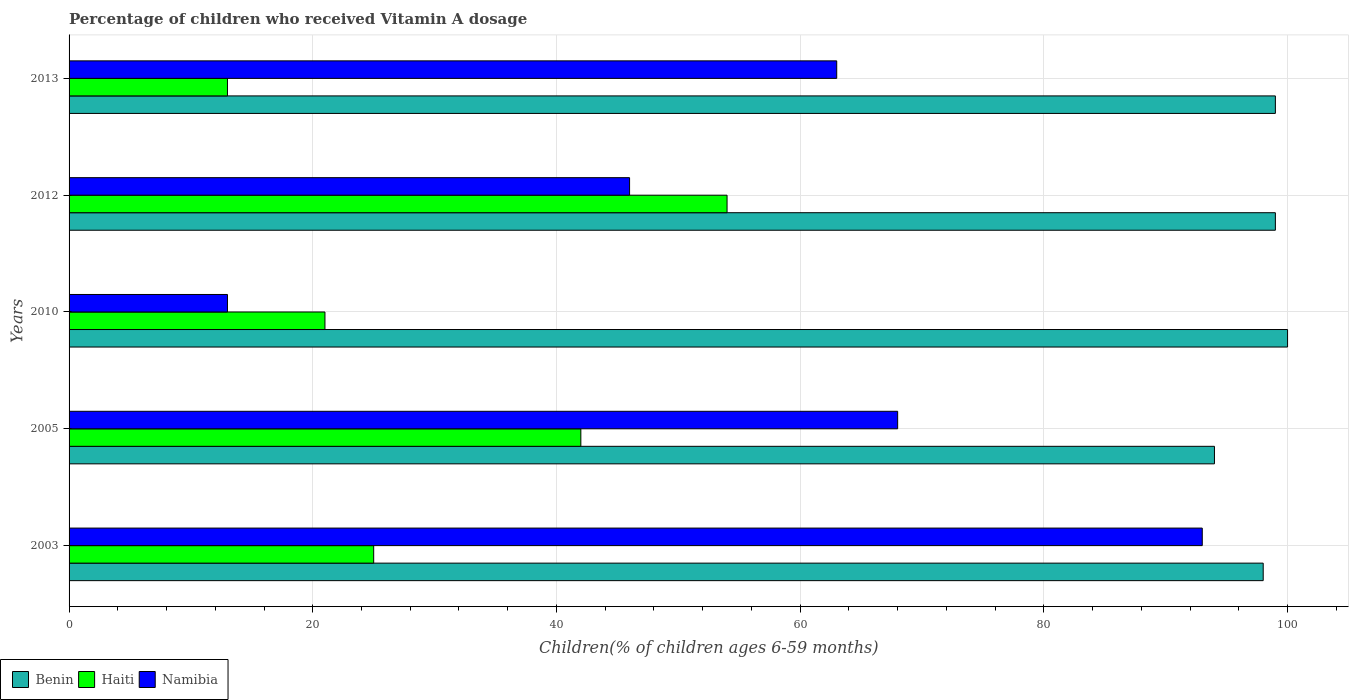How many different coloured bars are there?
Give a very brief answer. 3. What is the label of the 5th group of bars from the top?
Your response must be concise. 2003. What is the percentage of children who received Vitamin A dosage in Haiti in 2003?
Give a very brief answer. 25. Across all years, what is the maximum percentage of children who received Vitamin A dosage in Namibia?
Offer a very short reply. 93. Across all years, what is the minimum percentage of children who received Vitamin A dosage in Haiti?
Keep it short and to the point. 13. In which year was the percentage of children who received Vitamin A dosage in Namibia maximum?
Keep it short and to the point. 2003. In which year was the percentage of children who received Vitamin A dosage in Benin minimum?
Provide a short and direct response. 2005. What is the total percentage of children who received Vitamin A dosage in Haiti in the graph?
Provide a short and direct response. 155. What is the difference between the percentage of children who received Vitamin A dosage in Benin in 2005 and that in 2012?
Provide a short and direct response. -5. What is the difference between the percentage of children who received Vitamin A dosage in Namibia in 2013 and the percentage of children who received Vitamin A dosage in Benin in 2003?
Your response must be concise. -35. What is the average percentage of children who received Vitamin A dosage in Benin per year?
Offer a very short reply. 98. Is the difference between the percentage of children who received Vitamin A dosage in Namibia in 2005 and 2012 greater than the difference between the percentage of children who received Vitamin A dosage in Haiti in 2005 and 2012?
Offer a terse response. Yes. What is the difference between the highest and the second highest percentage of children who received Vitamin A dosage in Namibia?
Offer a very short reply. 25. What is the difference between the highest and the lowest percentage of children who received Vitamin A dosage in Haiti?
Make the answer very short. 41. In how many years, is the percentage of children who received Vitamin A dosage in Benin greater than the average percentage of children who received Vitamin A dosage in Benin taken over all years?
Offer a terse response. 3. What does the 1st bar from the top in 2010 represents?
Your response must be concise. Namibia. What does the 1st bar from the bottom in 2013 represents?
Your answer should be compact. Benin. Are all the bars in the graph horizontal?
Provide a short and direct response. Yes. What is the difference between two consecutive major ticks on the X-axis?
Make the answer very short. 20. Are the values on the major ticks of X-axis written in scientific E-notation?
Your answer should be very brief. No. Does the graph contain grids?
Offer a terse response. Yes. Where does the legend appear in the graph?
Keep it short and to the point. Bottom left. How are the legend labels stacked?
Give a very brief answer. Horizontal. What is the title of the graph?
Make the answer very short. Percentage of children who received Vitamin A dosage. Does "Bahrain" appear as one of the legend labels in the graph?
Offer a very short reply. No. What is the label or title of the X-axis?
Your response must be concise. Children(% of children ages 6-59 months). What is the label or title of the Y-axis?
Provide a succinct answer. Years. What is the Children(% of children ages 6-59 months) in Namibia in 2003?
Offer a very short reply. 93. What is the Children(% of children ages 6-59 months) in Benin in 2005?
Ensure brevity in your answer.  94. What is the Children(% of children ages 6-59 months) of Haiti in 2005?
Your answer should be compact. 42. What is the Children(% of children ages 6-59 months) in Namibia in 2005?
Ensure brevity in your answer.  68. What is the Children(% of children ages 6-59 months) of Benin in 2010?
Your answer should be compact. 100. What is the Children(% of children ages 6-59 months) of Haiti in 2012?
Make the answer very short. 54. What is the Children(% of children ages 6-59 months) of Haiti in 2013?
Your response must be concise. 13. Across all years, what is the maximum Children(% of children ages 6-59 months) in Benin?
Ensure brevity in your answer.  100. Across all years, what is the maximum Children(% of children ages 6-59 months) in Haiti?
Your answer should be compact. 54. Across all years, what is the maximum Children(% of children ages 6-59 months) of Namibia?
Keep it short and to the point. 93. Across all years, what is the minimum Children(% of children ages 6-59 months) in Benin?
Your response must be concise. 94. Across all years, what is the minimum Children(% of children ages 6-59 months) in Haiti?
Offer a terse response. 13. Across all years, what is the minimum Children(% of children ages 6-59 months) in Namibia?
Provide a succinct answer. 13. What is the total Children(% of children ages 6-59 months) of Benin in the graph?
Your answer should be compact. 490. What is the total Children(% of children ages 6-59 months) of Haiti in the graph?
Your answer should be compact. 155. What is the total Children(% of children ages 6-59 months) in Namibia in the graph?
Your answer should be very brief. 283. What is the difference between the Children(% of children ages 6-59 months) of Haiti in 2003 and that in 2005?
Ensure brevity in your answer.  -17. What is the difference between the Children(% of children ages 6-59 months) in Benin in 2003 and that in 2010?
Your answer should be compact. -2. What is the difference between the Children(% of children ages 6-59 months) of Haiti in 2003 and that in 2010?
Keep it short and to the point. 4. What is the difference between the Children(% of children ages 6-59 months) of Benin in 2003 and that in 2012?
Offer a terse response. -1. What is the difference between the Children(% of children ages 6-59 months) of Namibia in 2003 and that in 2012?
Provide a succinct answer. 47. What is the difference between the Children(% of children ages 6-59 months) of Benin in 2003 and that in 2013?
Your response must be concise. -1. What is the difference between the Children(% of children ages 6-59 months) of Namibia in 2003 and that in 2013?
Your answer should be compact. 30. What is the difference between the Children(% of children ages 6-59 months) of Haiti in 2005 and that in 2010?
Keep it short and to the point. 21. What is the difference between the Children(% of children ages 6-59 months) of Benin in 2005 and that in 2012?
Provide a short and direct response. -5. What is the difference between the Children(% of children ages 6-59 months) in Namibia in 2005 and that in 2012?
Give a very brief answer. 22. What is the difference between the Children(% of children ages 6-59 months) in Benin in 2005 and that in 2013?
Give a very brief answer. -5. What is the difference between the Children(% of children ages 6-59 months) in Haiti in 2005 and that in 2013?
Your response must be concise. 29. What is the difference between the Children(% of children ages 6-59 months) of Benin in 2010 and that in 2012?
Give a very brief answer. 1. What is the difference between the Children(% of children ages 6-59 months) of Haiti in 2010 and that in 2012?
Offer a very short reply. -33. What is the difference between the Children(% of children ages 6-59 months) in Namibia in 2010 and that in 2012?
Ensure brevity in your answer.  -33. What is the difference between the Children(% of children ages 6-59 months) in Benin in 2010 and that in 2013?
Provide a short and direct response. 1. What is the difference between the Children(% of children ages 6-59 months) in Haiti in 2010 and that in 2013?
Give a very brief answer. 8. What is the difference between the Children(% of children ages 6-59 months) of Benin in 2012 and that in 2013?
Provide a succinct answer. 0. What is the difference between the Children(% of children ages 6-59 months) of Benin in 2003 and the Children(% of children ages 6-59 months) of Haiti in 2005?
Give a very brief answer. 56. What is the difference between the Children(% of children ages 6-59 months) of Benin in 2003 and the Children(% of children ages 6-59 months) of Namibia in 2005?
Make the answer very short. 30. What is the difference between the Children(% of children ages 6-59 months) in Haiti in 2003 and the Children(% of children ages 6-59 months) in Namibia in 2005?
Provide a short and direct response. -43. What is the difference between the Children(% of children ages 6-59 months) of Benin in 2003 and the Children(% of children ages 6-59 months) of Haiti in 2010?
Provide a succinct answer. 77. What is the difference between the Children(% of children ages 6-59 months) in Haiti in 2003 and the Children(% of children ages 6-59 months) in Namibia in 2010?
Give a very brief answer. 12. What is the difference between the Children(% of children ages 6-59 months) of Benin in 2003 and the Children(% of children ages 6-59 months) of Namibia in 2012?
Make the answer very short. 52. What is the difference between the Children(% of children ages 6-59 months) in Haiti in 2003 and the Children(% of children ages 6-59 months) in Namibia in 2012?
Offer a terse response. -21. What is the difference between the Children(% of children ages 6-59 months) of Benin in 2003 and the Children(% of children ages 6-59 months) of Namibia in 2013?
Provide a succinct answer. 35. What is the difference between the Children(% of children ages 6-59 months) of Haiti in 2003 and the Children(% of children ages 6-59 months) of Namibia in 2013?
Your response must be concise. -38. What is the difference between the Children(% of children ages 6-59 months) of Haiti in 2005 and the Children(% of children ages 6-59 months) of Namibia in 2010?
Ensure brevity in your answer.  29. What is the difference between the Children(% of children ages 6-59 months) in Haiti in 2005 and the Children(% of children ages 6-59 months) in Namibia in 2012?
Give a very brief answer. -4. What is the difference between the Children(% of children ages 6-59 months) in Benin in 2005 and the Children(% of children ages 6-59 months) in Haiti in 2013?
Your answer should be very brief. 81. What is the difference between the Children(% of children ages 6-59 months) in Benin in 2005 and the Children(% of children ages 6-59 months) in Namibia in 2013?
Provide a succinct answer. 31. What is the difference between the Children(% of children ages 6-59 months) of Haiti in 2005 and the Children(% of children ages 6-59 months) of Namibia in 2013?
Keep it short and to the point. -21. What is the difference between the Children(% of children ages 6-59 months) in Benin in 2010 and the Children(% of children ages 6-59 months) in Namibia in 2012?
Keep it short and to the point. 54. What is the difference between the Children(% of children ages 6-59 months) in Benin in 2010 and the Children(% of children ages 6-59 months) in Haiti in 2013?
Keep it short and to the point. 87. What is the difference between the Children(% of children ages 6-59 months) in Haiti in 2010 and the Children(% of children ages 6-59 months) in Namibia in 2013?
Your answer should be very brief. -42. What is the average Children(% of children ages 6-59 months) of Namibia per year?
Keep it short and to the point. 56.6. In the year 2003, what is the difference between the Children(% of children ages 6-59 months) of Benin and Children(% of children ages 6-59 months) of Namibia?
Provide a short and direct response. 5. In the year 2003, what is the difference between the Children(% of children ages 6-59 months) of Haiti and Children(% of children ages 6-59 months) of Namibia?
Ensure brevity in your answer.  -68. In the year 2005, what is the difference between the Children(% of children ages 6-59 months) of Haiti and Children(% of children ages 6-59 months) of Namibia?
Ensure brevity in your answer.  -26. In the year 2010, what is the difference between the Children(% of children ages 6-59 months) in Benin and Children(% of children ages 6-59 months) in Haiti?
Provide a succinct answer. 79. In the year 2010, what is the difference between the Children(% of children ages 6-59 months) of Haiti and Children(% of children ages 6-59 months) of Namibia?
Make the answer very short. 8. In the year 2012, what is the difference between the Children(% of children ages 6-59 months) in Haiti and Children(% of children ages 6-59 months) in Namibia?
Your answer should be very brief. 8. In the year 2013, what is the difference between the Children(% of children ages 6-59 months) in Benin and Children(% of children ages 6-59 months) in Haiti?
Your answer should be compact. 86. What is the ratio of the Children(% of children ages 6-59 months) of Benin in 2003 to that in 2005?
Make the answer very short. 1.04. What is the ratio of the Children(% of children ages 6-59 months) in Haiti in 2003 to that in 2005?
Ensure brevity in your answer.  0.6. What is the ratio of the Children(% of children ages 6-59 months) in Namibia in 2003 to that in 2005?
Your answer should be very brief. 1.37. What is the ratio of the Children(% of children ages 6-59 months) in Benin in 2003 to that in 2010?
Make the answer very short. 0.98. What is the ratio of the Children(% of children ages 6-59 months) of Haiti in 2003 to that in 2010?
Offer a terse response. 1.19. What is the ratio of the Children(% of children ages 6-59 months) of Namibia in 2003 to that in 2010?
Your answer should be compact. 7.15. What is the ratio of the Children(% of children ages 6-59 months) in Benin in 2003 to that in 2012?
Ensure brevity in your answer.  0.99. What is the ratio of the Children(% of children ages 6-59 months) of Haiti in 2003 to that in 2012?
Ensure brevity in your answer.  0.46. What is the ratio of the Children(% of children ages 6-59 months) in Namibia in 2003 to that in 2012?
Keep it short and to the point. 2.02. What is the ratio of the Children(% of children ages 6-59 months) in Benin in 2003 to that in 2013?
Your answer should be compact. 0.99. What is the ratio of the Children(% of children ages 6-59 months) of Haiti in 2003 to that in 2013?
Keep it short and to the point. 1.92. What is the ratio of the Children(% of children ages 6-59 months) in Namibia in 2003 to that in 2013?
Ensure brevity in your answer.  1.48. What is the ratio of the Children(% of children ages 6-59 months) of Namibia in 2005 to that in 2010?
Make the answer very short. 5.23. What is the ratio of the Children(% of children ages 6-59 months) in Benin in 2005 to that in 2012?
Offer a terse response. 0.95. What is the ratio of the Children(% of children ages 6-59 months) of Namibia in 2005 to that in 2012?
Your answer should be compact. 1.48. What is the ratio of the Children(% of children ages 6-59 months) in Benin in 2005 to that in 2013?
Your answer should be very brief. 0.95. What is the ratio of the Children(% of children ages 6-59 months) of Haiti in 2005 to that in 2013?
Your answer should be very brief. 3.23. What is the ratio of the Children(% of children ages 6-59 months) in Namibia in 2005 to that in 2013?
Your answer should be very brief. 1.08. What is the ratio of the Children(% of children ages 6-59 months) in Benin in 2010 to that in 2012?
Provide a succinct answer. 1.01. What is the ratio of the Children(% of children ages 6-59 months) of Haiti in 2010 to that in 2012?
Your response must be concise. 0.39. What is the ratio of the Children(% of children ages 6-59 months) of Namibia in 2010 to that in 2012?
Offer a very short reply. 0.28. What is the ratio of the Children(% of children ages 6-59 months) of Haiti in 2010 to that in 2013?
Ensure brevity in your answer.  1.62. What is the ratio of the Children(% of children ages 6-59 months) of Namibia in 2010 to that in 2013?
Make the answer very short. 0.21. What is the ratio of the Children(% of children ages 6-59 months) of Haiti in 2012 to that in 2013?
Your answer should be compact. 4.15. What is the ratio of the Children(% of children ages 6-59 months) in Namibia in 2012 to that in 2013?
Keep it short and to the point. 0.73. What is the difference between the highest and the second highest Children(% of children ages 6-59 months) of Haiti?
Provide a succinct answer. 12. What is the difference between the highest and the second highest Children(% of children ages 6-59 months) of Namibia?
Your answer should be very brief. 25. What is the difference between the highest and the lowest Children(% of children ages 6-59 months) of Benin?
Keep it short and to the point. 6. 